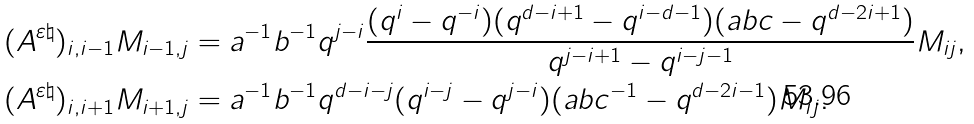<formula> <loc_0><loc_0><loc_500><loc_500>( A ^ { \varepsilon \natural } ) _ { i , i - 1 } M _ { i - 1 , j } & = a ^ { - 1 } b ^ { - 1 } q ^ { j - i } \frac { ( q ^ { i } - q ^ { - i } ) ( q ^ { d - i + 1 } - q ^ { i - d - 1 } ) ( a b c - q ^ { d - 2 i + 1 } ) } { q ^ { j - i + 1 } - q ^ { i - j - 1 } } M _ { i j } , \\ ( A ^ { \varepsilon \natural } ) _ { i , i + 1 } M _ { i + 1 , j } & = a ^ { - 1 } b ^ { - 1 } q ^ { d - i - j } ( q ^ { i - j } - q ^ { j - i } ) ( a b c ^ { - 1 } - q ^ { d - 2 i - 1 } ) M _ { i j } .</formula> 